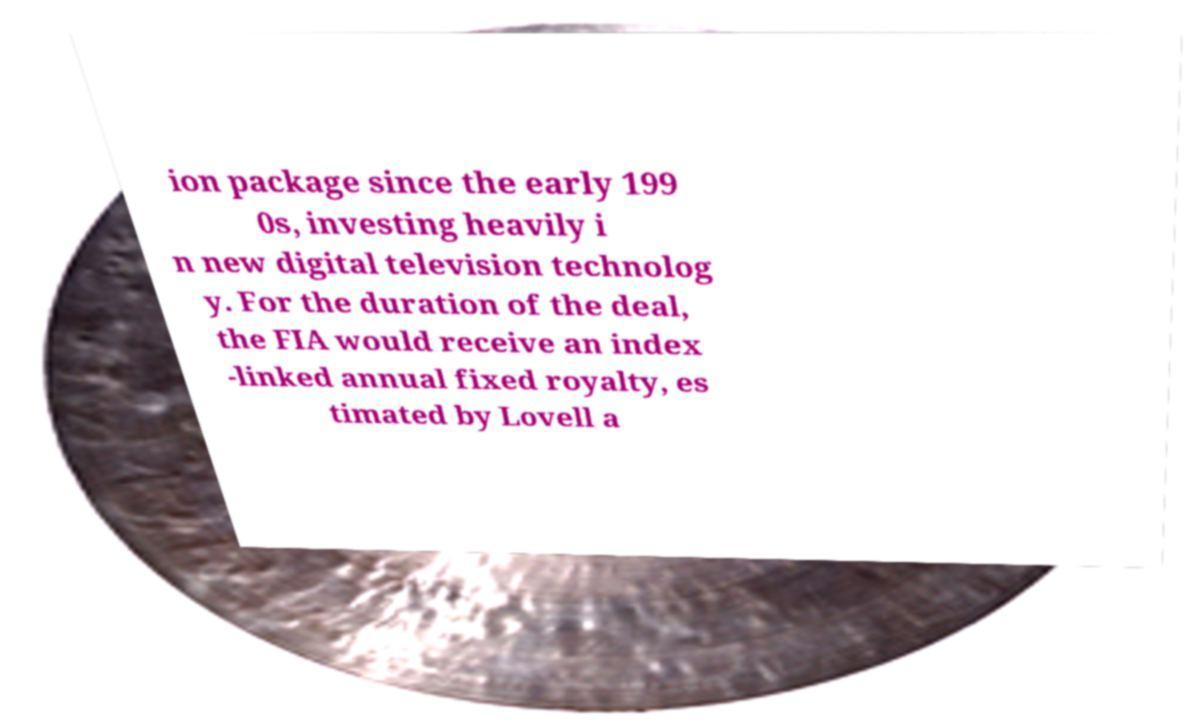Could you extract and type out the text from this image? ion package since the early 199 0s, investing heavily i n new digital television technolog y. For the duration of the deal, the FIA would receive an index -linked annual fixed royalty, es timated by Lovell a 